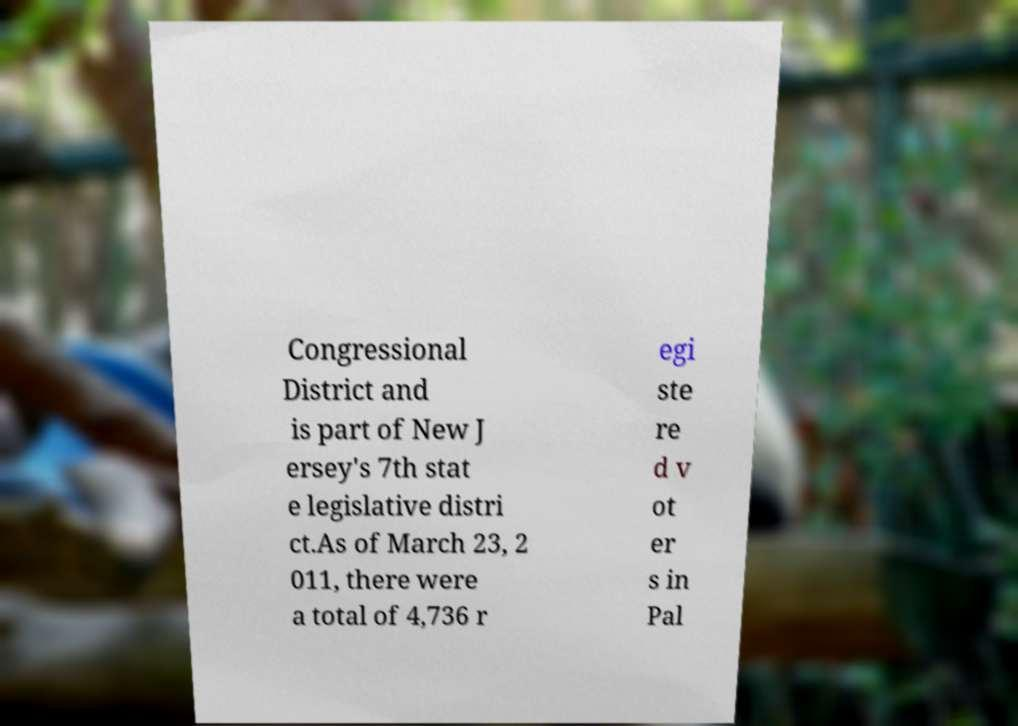Could you extract and type out the text from this image? Congressional District and is part of New J ersey's 7th stat e legislative distri ct.As of March 23, 2 011, there were a total of 4,736 r egi ste re d v ot er s in Pal 